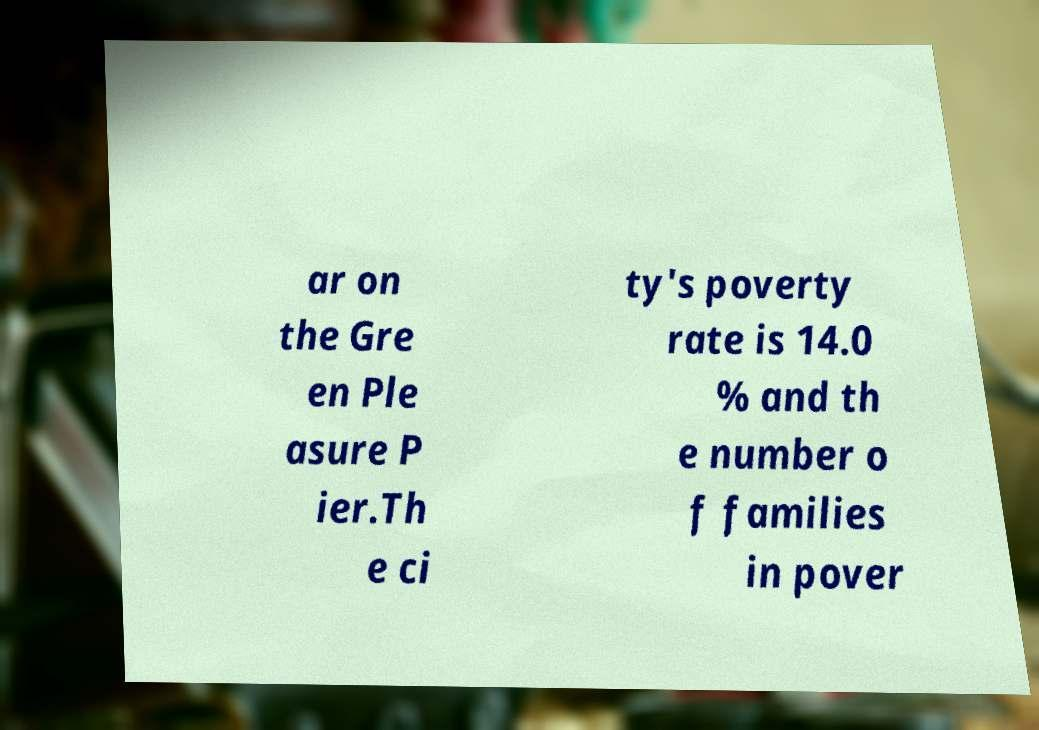For documentation purposes, I need the text within this image transcribed. Could you provide that? ar on the Gre en Ple asure P ier.Th e ci ty's poverty rate is 14.0 % and th e number o f families in pover 